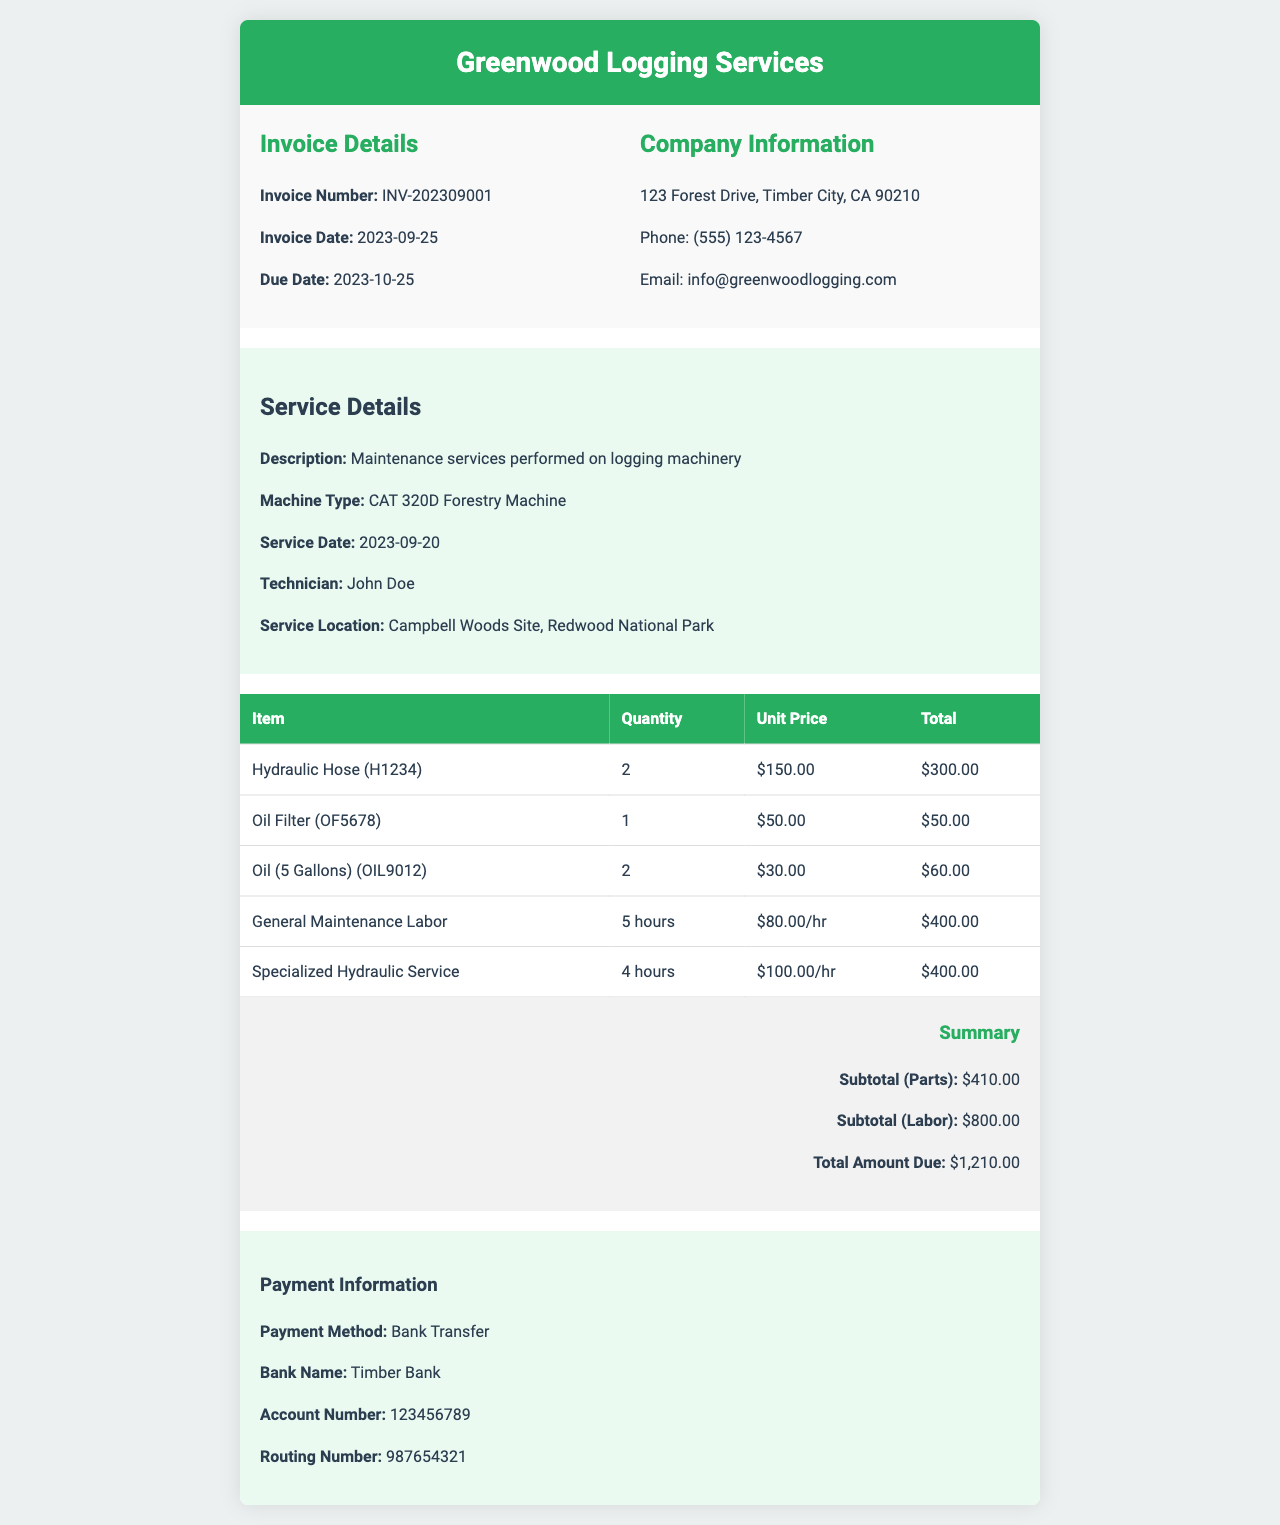What is the invoice number? The invoice number is explicitly stated in the invoice details section.
Answer: INV-202309001 What is the total amount due? The total amount due is clearly summarized in the invoice summary section.
Answer: $1,210.00 Who is the technician that performed the service? The technician's name is mentioned in the service details section.
Answer: John Doe What is the service date? The service date is provided in the service details section of the invoice.
Answer: 2023-09-20 How many hydraulic hoses were charged? The quantity of hydraulic hoses is shown in the table of itemized parts.
Answer: 2 What is the subtotal for labor costs? The subtotal for labor costs is outlined in the invoice summary section.
Answer: $800.00 What type of payment method is accepted? The payment method is specified in the payment information section.
Answer: Bank Transfer Where is the service location? The service location is given in the service details section.
Answer: Campbell Woods Site, Redwood National Park What is the unit price of the oil filter? The unit price of the oil filter can be found in the itemized table.
Answer: $50.00 